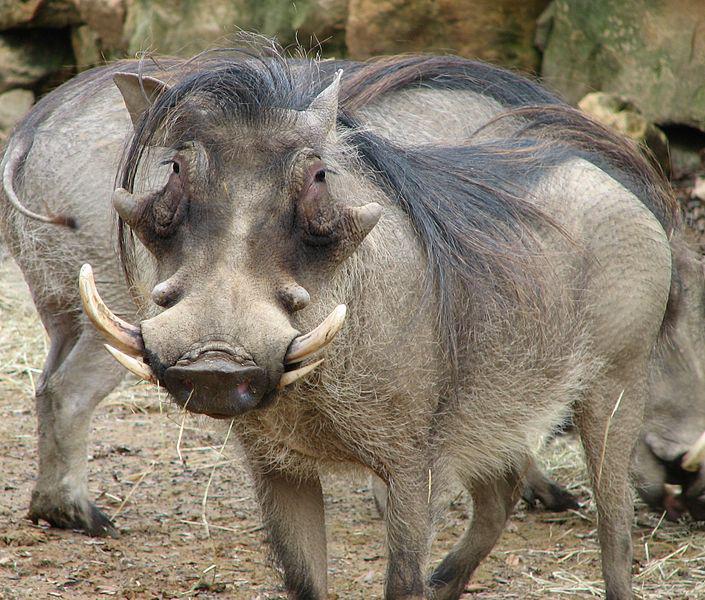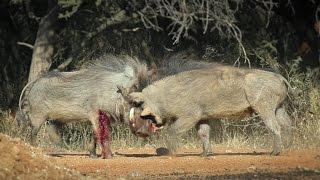The first image is the image on the left, the second image is the image on the right. For the images shown, is this caption "A hog's leg is bleeding while it fights another hog." true? Answer yes or no. Yes. 